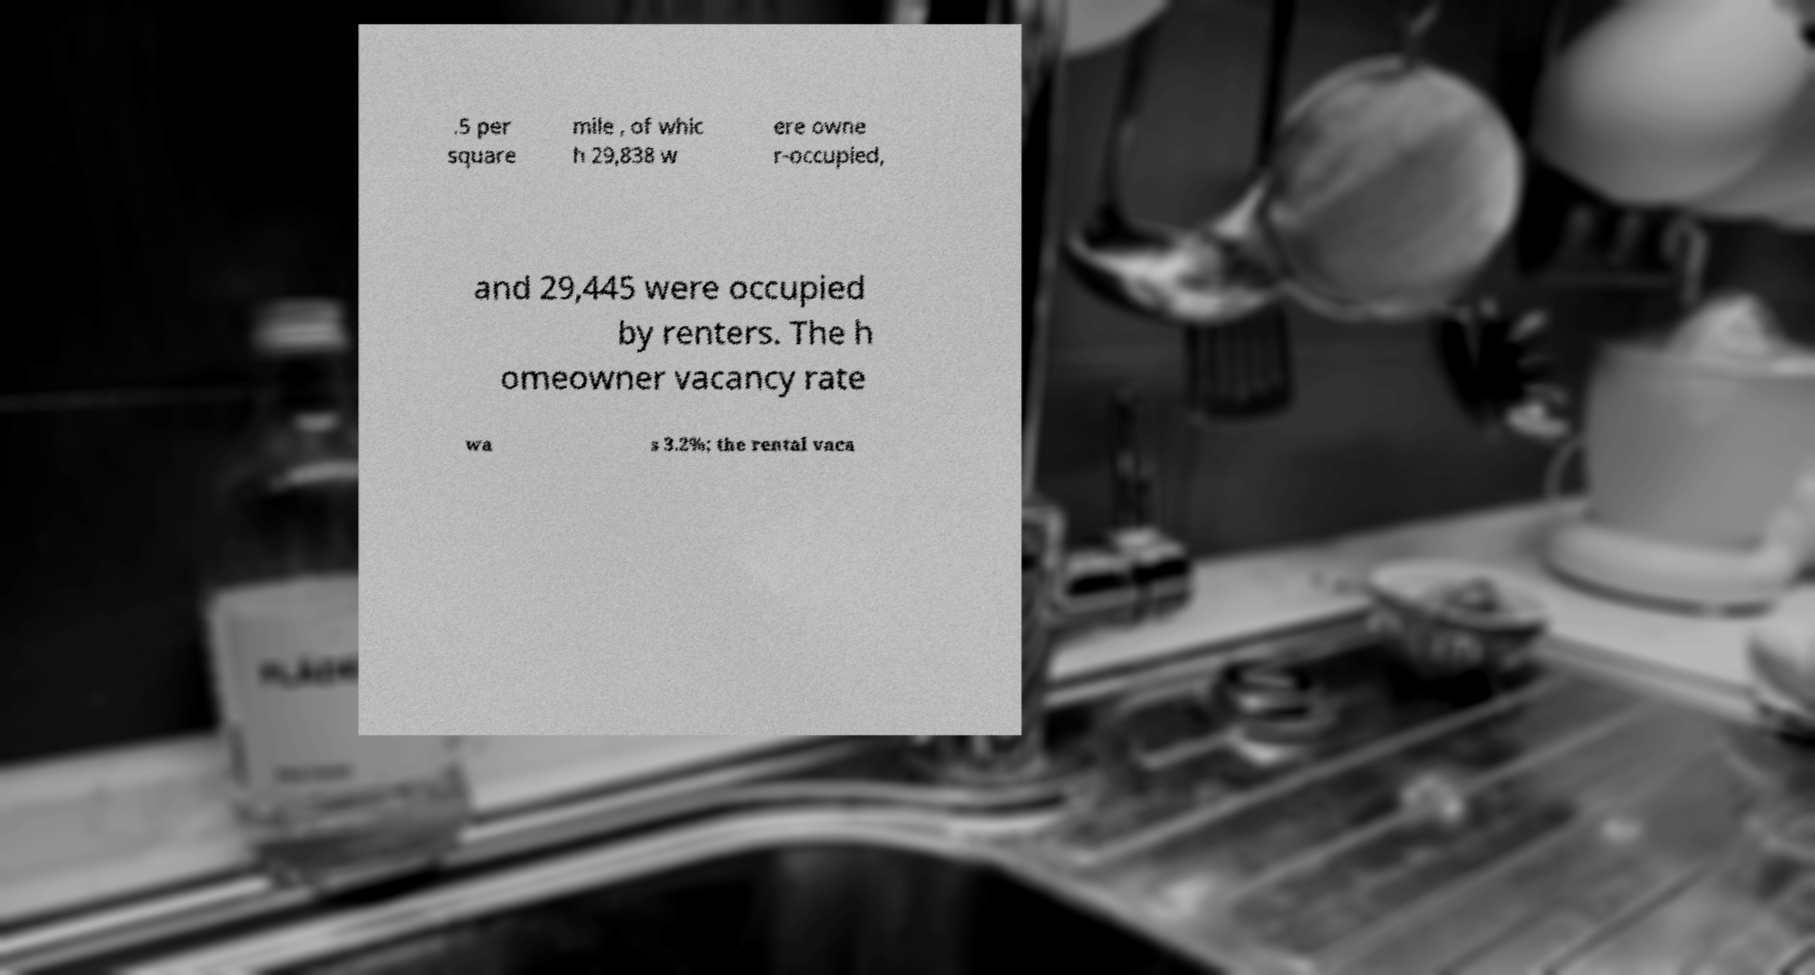Can you read and provide the text displayed in the image?This photo seems to have some interesting text. Can you extract and type it out for me? .5 per square mile , of whic h 29,838 w ere owne r-occupied, and 29,445 were occupied by renters. The h omeowner vacancy rate wa s 3.2%; the rental vaca 